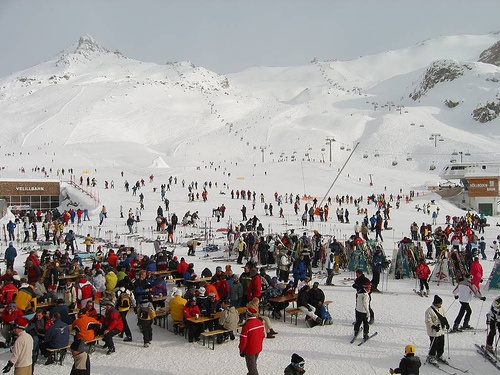Describe the objects in this image and their specific colors. I can see people in darkgray, black, lightgray, and gray tones, people in darkgray, brown, maroon, black, and gray tones, people in darkgray, black, gray, and lightgray tones, people in darkgray, black, gray, and lightgray tones, and people in darkgray, tan, gray, and black tones in this image. 